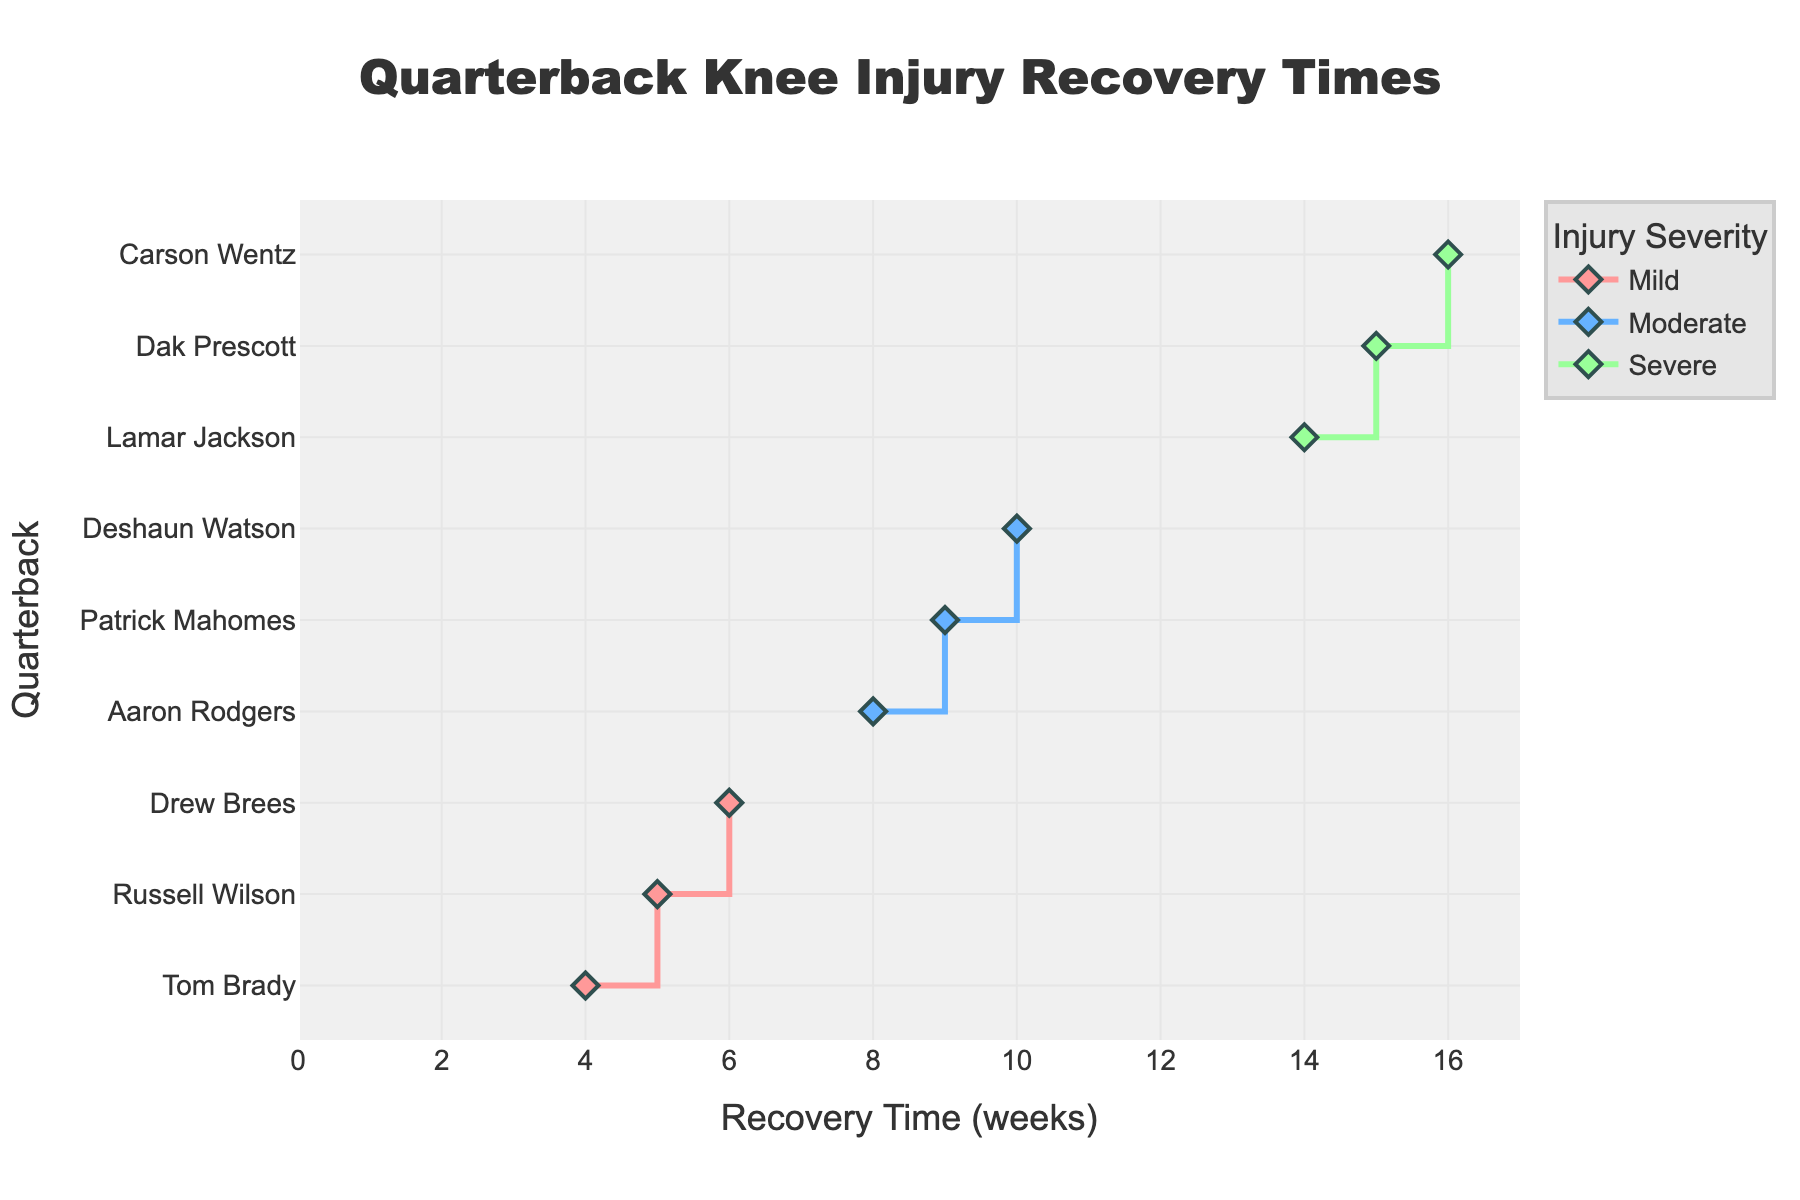What is the title of the figure? The title is the text displayed at the top of the figure which describes what the figure is about. In this case, it's about recovery times for quarterbacks.
Answer: Quarterback Knee Injury Recovery Times What is the range of recovery times for severe injuries? To find the range, identify the minimum and maximum recovery times for severe injuries. The quarterbacks with severe injuries have recovery times of 14, 15, and 16 weeks. The range is the difference between the maximum and minimum values.
Answer: 14 - 16 weeks Which severity level has the shortest recovery time? To determine this, look at the recovery times associated with each severity level. The shortest recovery time corresponds to the 'Mild' severity level at 4 weeks.
Answer: Mild How many quarterbacks have moderate severity injuries? Count the data points associated with the moderate severity level. According to the figure, there are three quarterbacks with moderate injuries.
Answer: 3 Who has the longest recovery time and what is its value? Look at the quarterback with the highest recovery time. Carson Wentz has the longest recovery time of 16 weeks.
Answer: Carson Wentz, 16 weeks Among quarterbacks with mild injuries, who has the longest recovery time? Focus on the quarterbacks with mild injuries and identify the longest recovery time. Drew Brees has the longest recovery time among those with mild injuries, which is 6 weeks.
Answer: Drew Brees, 6 weeks Compare the shortest recovery time of severe injuries and the longest recovery time of mild injuries. What is the difference? Identify the values first: the shortest recovery time for severe injuries is 14 weeks, and the longest recovery time for mild injuries is 6 weeks. Subtract 6 from 14 to find the difference.
Answer: 8 weeks Which quarterback has a recovery time equal to the average recovery time for moderate injuries? Calculate the average recovery time for moderate injuries: (8 + 9 + 10) / 3 = 9 weeks. Then find the quarterback with this recovery time. Patrick Mahomes has a recovery time of 9 weeks.
Answer: Patrick Mahomes What are the colors used for each severity level? Look at the colors representing each severity level: Mild injuries are shown in a pinkish-red, moderate injuries in a bluish color, and severe injuries in a greenish color.
Answer: Mild: pinkish-red, Moderate: blue, Severe: green Who are the quarterbacks with recovery times greater than 10 weeks? Identify the data points where the recovery time exceeds 10 weeks. The quarterbacks with recovery times greater than 10 weeks are Dak Prescott, Lamar Jackson, and Carson Wentz.
Answer: Dak Prescott, Lamar Jackson, Carson Wentz 